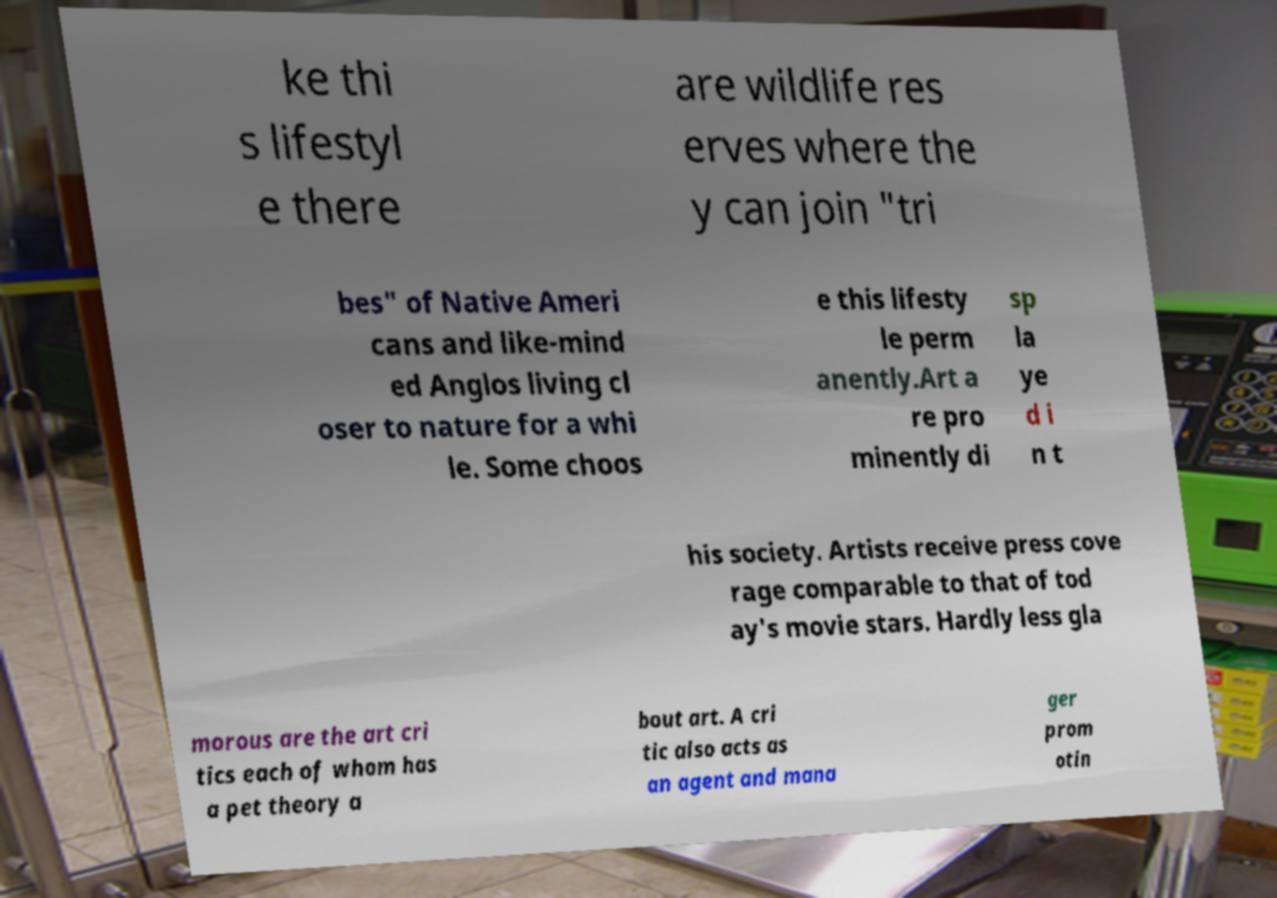Could you assist in decoding the text presented in this image and type it out clearly? ke thi s lifestyl e there are wildlife res erves where the y can join "tri bes" of Native Ameri cans and like-mind ed Anglos living cl oser to nature for a whi le. Some choos e this lifesty le perm anently.Art a re pro minently di sp la ye d i n t his society. Artists receive press cove rage comparable to that of tod ay's movie stars. Hardly less gla morous are the art cri tics each of whom has a pet theory a bout art. A cri tic also acts as an agent and mana ger prom otin 